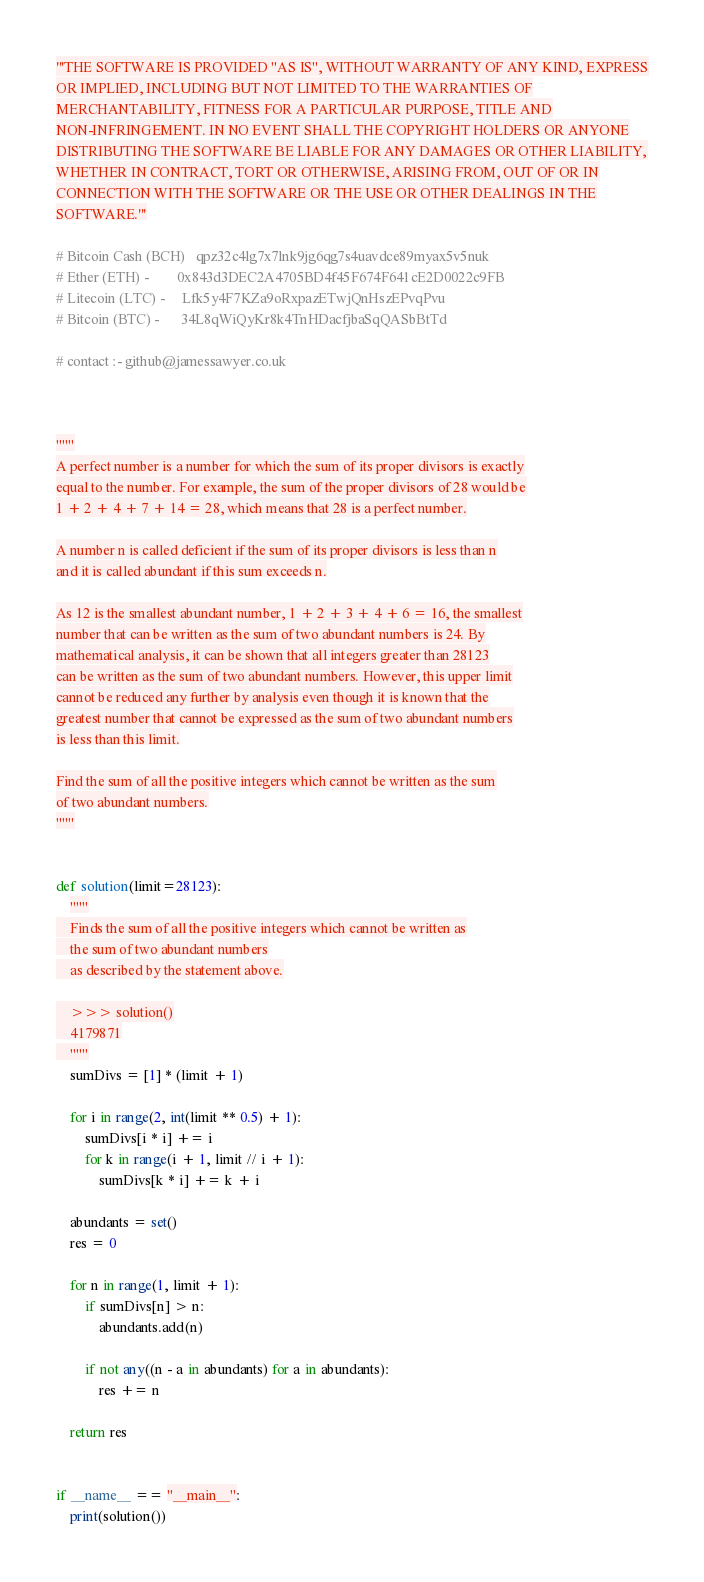<code> <loc_0><loc_0><loc_500><loc_500><_Python_>'''THE SOFTWARE IS PROVIDED "AS IS", WITHOUT WARRANTY OF ANY KIND, EXPRESS
OR IMPLIED, INCLUDING BUT NOT LIMITED TO THE WARRANTIES OF
MERCHANTABILITY, FITNESS FOR A PARTICULAR PURPOSE, TITLE AND
NON-INFRINGEMENT. IN NO EVENT SHALL THE COPYRIGHT HOLDERS OR ANYONE
DISTRIBUTING THE SOFTWARE BE LIABLE FOR ANY DAMAGES OR OTHER LIABILITY,
WHETHER IN CONTRACT, TORT OR OTHERWISE, ARISING FROM, OUT OF OR IN
CONNECTION WITH THE SOFTWARE OR THE USE OR OTHER DEALINGS IN THE
SOFTWARE.'''

# Bitcoin Cash (BCH)   qpz32c4lg7x7lnk9jg6qg7s4uavdce89myax5v5nuk
# Ether (ETH) -        0x843d3DEC2A4705BD4f45F674F641cE2D0022c9FB
# Litecoin (LTC) -     Lfk5y4F7KZa9oRxpazETwjQnHszEPvqPvu
# Bitcoin (BTC) -      34L8qWiQyKr8k4TnHDacfjbaSqQASbBtTd

# contact :- github@jamessawyer.co.uk



"""
A perfect number is a number for which the sum of its proper divisors is exactly
equal to the number. For example, the sum of the proper divisors of 28 would be
1 + 2 + 4 + 7 + 14 = 28, which means that 28 is a perfect number.

A number n is called deficient if the sum of its proper divisors is less than n
and it is called abundant if this sum exceeds n.

As 12 is the smallest abundant number, 1 + 2 + 3 + 4 + 6 = 16, the smallest
number that can be written as the sum of two abundant numbers is 24. By
mathematical analysis, it can be shown that all integers greater than 28123
can be written as the sum of two abundant numbers. However, this upper limit
cannot be reduced any further by analysis even though it is known that the
greatest number that cannot be expressed as the sum of two abundant numbers
is less than this limit.

Find the sum of all the positive integers which cannot be written as the sum
of two abundant numbers.
"""


def solution(limit=28123):
    """
    Finds the sum of all the positive integers which cannot be written as
    the sum of two abundant numbers
    as described by the statement above.

    >>> solution()
    4179871
    """
    sumDivs = [1] * (limit + 1)

    for i in range(2, int(limit ** 0.5) + 1):
        sumDivs[i * i] += i
        for k in range(i + 1, limit // i + 1):
            sumDivs[k * i] += k + i

    abundants = set()
    res = 0

    for n in range(1, limit + 1):
        if sumDivs[n] > n:
            abundants.add(n)

        if not any((n - a in abundants) for a in abundants):
            res += n

    return res


if __name__ == "__main__":
    print(solution())
</code> 